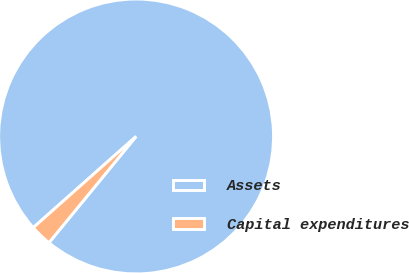Convert chart. <chart><loc_0><loc_0><loc_500><loc_500><pie_chart><fcel>Assets<fcel>Capital expenditures<nl><fcel>97.48%<fcel>2.52%<nl></chart> 